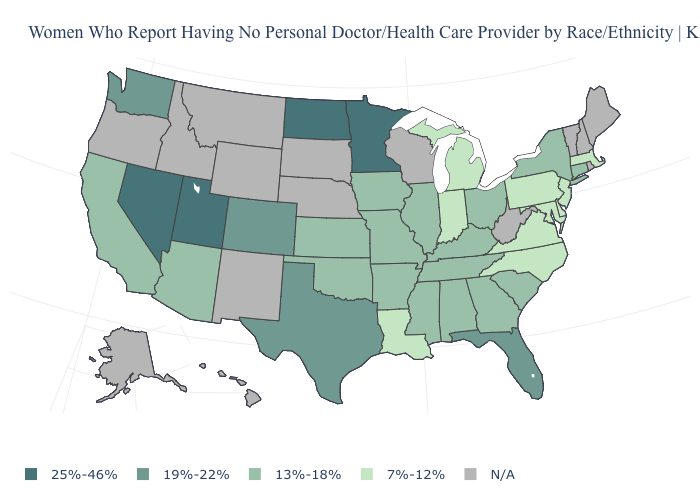What is the value of Virginia?
Concise answer only. 7%-12%. Does the first symbol in the legend represent the smallest category?
Quick response, please. No. What is the value of Georgia?
Short answer required. 13%-18%. What is the value of North Carolina?
Give a very brief answer. 7%-12%. What is the value of Idaho?
Be succinct. N/A. Name the states that have a value in the range 13%-18%?
Write a very short answer. Alabama, Arizona, Arkansas, California, Connecticut, Georgia, Illinois, Iowa, Kansas, Kentucky, Mississippi, Missouri, New York, Ohio, Oklahoma, South Carolina, Tennessee. Which states have the lowest value in the USA?
Be succinct. Delaware, Indiana, Louisiana, Maryland, Massachusetts, Michigan, New Jersey, North Carolina, Pennsylvania, Virginia. What is the value of North Dakota?
Write a very short answer. 25%-46%. Name the states that have a value in the range 25%-46%?
Give a very brief answer. Minnesota, Nevada, North Dakota, Utah. What is the value of Oregon?
Keep it brief. N/A. Among the states that border Arizona , does Colorado have the highest value?
Be succinct. No. What is the value of Tennessee?
Be succinct. 13%-18%. What is the value of Iowa?
Concise answer only. 13%-18%. Name the states that have a value in the range 7%-12%?
Keep it brief. Delaware, Indiana, Louisiana, Maryland, Massachusetts, Michigan, New Jersey, North Carolina, Pennsylvania, Virginia. 